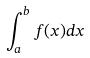Convert formula to latex. <formula><loc_0><loc_0><loc_500><loc_500>\int _ { a } ^ { b } f ( x ) d x</formula> 